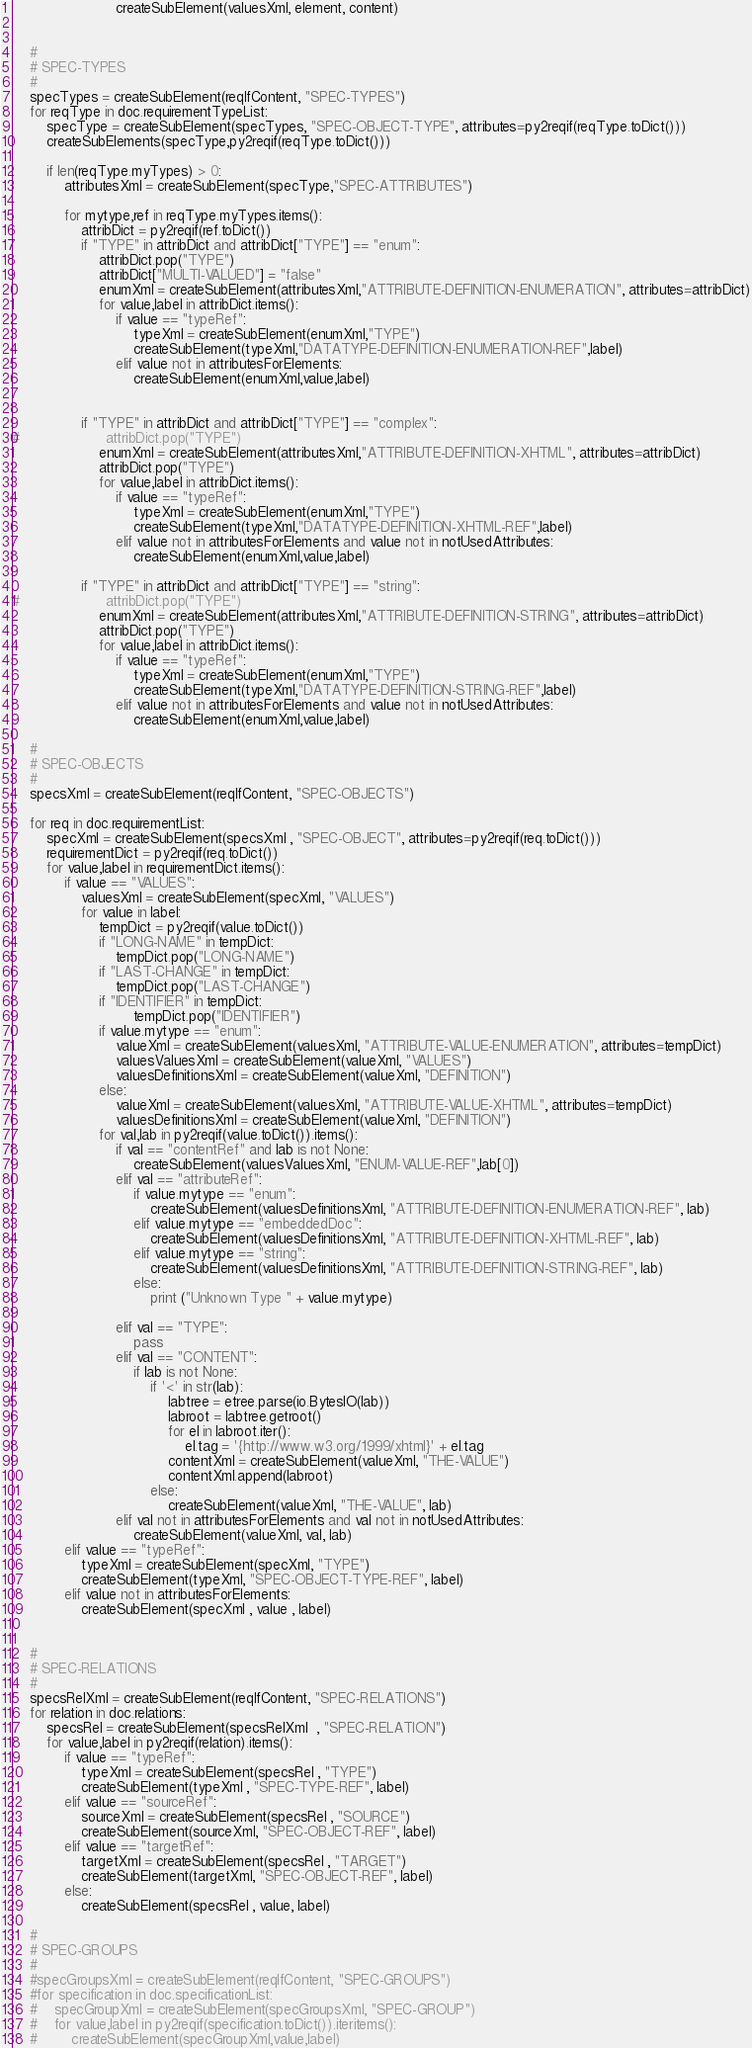Convert code to text. <code><loc_0><loc_0><loc_500><loc_500><_Python_>                        createSubElement(valuesXml, element, content)

    
    #
    # SPEC-TYPES
    #
    specTypes = createSubElement(reqIfContent, "SPEC-TYPES")
    for reqType in doc.requirementTypeList:
        specType = createSubElement(specTypes, "SPEC-OBJECT-TYPE", attributes=py2reqif(reqType.toDict()))
        createSubElements(specType,py2reqif(reqType.toDict()))
        
        if len(reqType.myTypes) > 0:
            attributesXml = createSubElement(specType,"SPEC-ATTRIBUTES")

            for mytype,ref in reqType.myTypes.items():
                attribDict = py2reqif(ref.toDict())
                if "TYPE" in attribDict and attribDict["TYPE"] == "enum":
                    attribDict.pop("TYPE")
                    attribDict["MULTI-VALUED"] = "false"
                    enumXml = createSubElement(attributesXml,"ATTRIBUTE-DEFINITION-ENUMERATION", attributes=attribDict)
                    for value,label in attribDict.items():
                        if value == "typeRef":
                            typeXml = createSubElement(enumXml,"TYPE")
                            createSubElement(typeXml,"DATATYPE-DEFINITION-ENUMERATION-REF",label)
                        elif value not in attributesForElements:
                            createSubElement(enumXml,value,label)


                if "TYPE" in attribDict and attribDict["TYPE"] == "complex":
#                    attribDict.pop("TYPE")
                    enumXml = createSubElement(attributesXml,"ATTRIBUTE-DEFINITION-XHTML", attributes=attribDict)
                    attribDict.pop("TYPE")
                    for value,label in attribDict.items():
                        if value == "typeRef":
                            typeXml = createSubElement(enumXml,"TYPE")
                            createSubElement(typeXml,"DATATYPE-DEFINITION-XHTML-REF",label)
                        elif value not in attributesForElements and value not in notUsedAttributes:
                            createSubElement(enumXml,value,label)

                if "TYPE" in attribDict and attribDict["TYPE"] == "string":
#                    attribDict.pop("TYPE")
                    enumXml = createSubElement(attributesXml,"ATTRIBUTE-DEFINITION-STRING", attributes=attribDict)
                    attribDict.pop("TYPE")
                    for value,label in attribDict.items():
                        if value == "typeRef":
                            typeXml = createSubElement(enumXml,"TYPE")
                            createSubElement(typeXml,"DATATYPE-DEFINITION-STRING-REF",label)
                        elif value not in attributesForElements and value not in notUsedAttributes:
                            createSubElement(enumXml,value,label)

    #
    # SPEC-OBJECTS
    #
    specsXml = createSubElement(reqIfContent, "SPEC-OBJECTS")
    
    for req in doc.requirementList:
        specXml = createSubElement(specsXml , "SPEC-OBJECT", attributes=py2reqif(req.toDict()))
        requirementDict = py2reqif(req.toDict())
        for value,label in requirementDict.items():
            if value == "VALUES":
                valuesXml = createSubElement(specXml, "VALUES")
                for value in label:
                    tempDict = py2reqif(value.toDict())
                    if "LONG-NAME" in tempDict:
                        tempDict.pop("LONG-NAME")
                    if "LAST-CHANGE" in tempDict:
                        tempDict.pop("LAST-CHANGE")
                    if "IDENTIFIER" in tempDict:
                            tempDict.pop("IDENTIFIER")
                    if value.mytype == "enum":
                        valueXml = createSubElement(valuesXml, "ATTRIBUTE-VALUE-ENUMERATION", attributes=tempDict)
                        valuesValuesXml = createSubElement(valueXml, "VALUES")
                        valuesDefinitionsXml = createSubElement(valueXml, "DEFINITION")
                    else:
                        valueXml = createSubElement(valuesXml, "ATTRIBUTE-VALUE-XHTML", attributes=tempDict)
                        valuesDefinitionsXml = createSubElement(valueXml, "DEFINITION")
                    for val,lab in py2reqif(value.toDict()).items():
                        if val == "contentRef" and lab is not None:
                            createSubElement(valuesValuesXml, "ENUM-VALUE-REF",lab[0])
                        elif val == "attributeRef":
                            if value.mytype == "enum":
                                createSubElement(valuesDefinitionsXml, "ATTRIBUTE-DEFINITION-ENUMERATION-REF", lab)
                            elif value.mytype == "embeddedDoc":
                                createSubElement(valuesDefinitionsXml, "ATTRIBUTE-DEFINITION-XHTML-REF", lab)
                            elif value.mytype == "string":
                                createSubElement(valuesDefinitionsXml, "ATTRIBUTE-DEFINITION-STRING-REF", lab)
                            else:
                                print ("Unknown Type " + value.mytype)
                            
                        elif val == "TYPE":
                            pass
                        elif val == "CONTENT":
                            if lab is not None:
                                if '<' in str(lab):
                                    labtree = etree.parse(io.BytesIO(lab))
                                    labroot = labtree.getroot()
                                    for el in labroot.iter():
                                        el.tag = '{http://www.w3.org/1999/xhtml}' + el.tag
                                    contentXml = createSubElement(valueXml, "THE-VALUE")
                                    contentXml.append(labroot)
                                else:
                                    createSubElement(valueXml, "THE-VALUE", lab)
                        elif val not in attributesForElements and val not in notUsedAttributes:
                            createSubElement(valueXml, val, lab)
            elif value == "typeRef":
                typeXml = createSubElement(specXml, "TYPE")
                createSubElement(typeXml, "SPEC-OBJECT-TYPE-REF", label)
            elif value not in attributesForElements:
                createSubElement(specXml , value , label)
            

    #
    # SPEC-RELATIONS
    #
    specsRelXml = createSubElement(reqIfContent, "SPEC-RELATIONS")
    for relation in doc.relations:
        specsRel = createSubElement(specsRelXml  , "SPEC-RELATION")
        for value,label in py2reqif(relation).items():
            if value == "typeRef":
                typeXml = createSubElement(specsRel , "TYPE")
                createSubElement(typeXml , "SPEC-TYPE-REF", label)
            elif value == "sourceRef":
                sourceXml = createSubElement(specsRel , "SOURCE")
                createSubElement(sourceXml, "SPEC-OBJECT-REF", label)
            elif value == "targetRef":
                targetXml = createSubElement(specsRel , "TARGET")
                createSubElement(targetXml, "SPEC-OBJECT-REF", label)
            else:
                createSubElement(specsRel , value, label)

    #
    # SPEC-GROUPS
    #
    #specGroupsXml = createSubElement(reqIfContent, "SPEC-GROUPS")
    #for specification in doc.specificationList:
    #    specGroupXml = createSubElement(specGroupsXml, "SPEC-GROUP")
    #    for value,label in py2reqif(specification.toDict()).iteritems():
    #        createSubElement(specGroupXml,value,label)</code> 